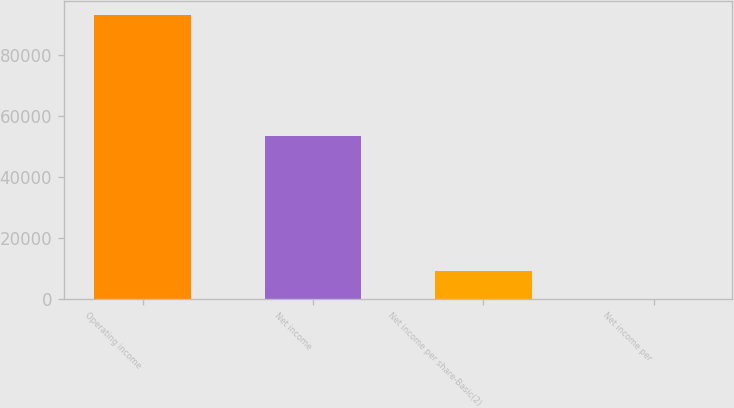Convert chart. <chart><loc_0><loc_0><loc_500><loc_500><bar_chart><fcel>Operating income<fcel>Net income<fcel>Net income per share-Basic(2)<fcel>Net income per<nl><fcel>93010<fcel>53341<fcel>9301.26<fcel>0.29<nl></chart> 